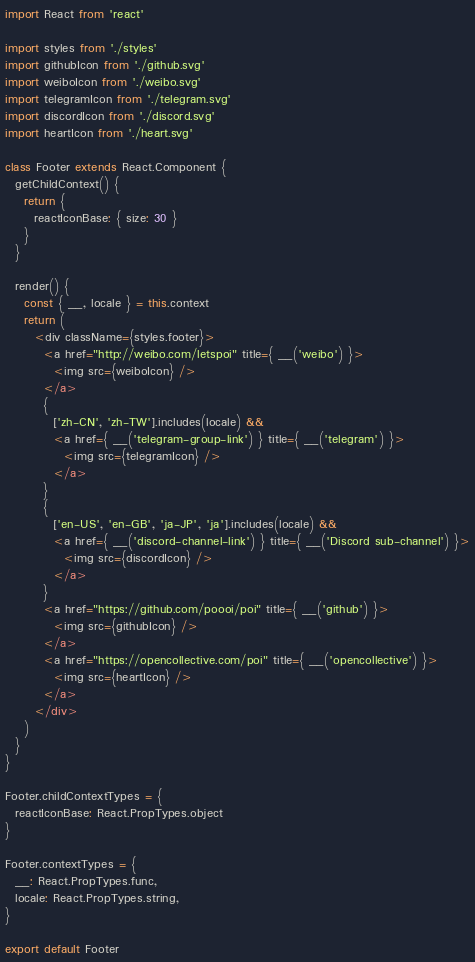<code> <loc_0><loc_0><loc_500><loc_500><_JavaScript_>import React from 'react'

import styles from './styles'
import githubIcon from './github.svg'
import weiboIcon from './weibo.svg'
import telegramIcon from './telegram.svg'
import discordIcon from './discord.svg'
import heartIcon from './heart.svg'

class Footer extends React.Component {
  getChildContext() {
    return {
      reactIconBase: { size: 30 }
    }
  }

  render() {
    const { __, locale } = this.context
    return (
      <div className={styles.footer}>
        <a href="http://weibo.com/letspoi" title={ __('weibo') }>
          <img src={weiboIcon} />
        </a>
        {
          ['zh-CN', 'zh-TW'].includes(locale) &&
          <a href={ __('telegram-group-link') } title={ __('telegram') }>
            <img src={telegramIcon} />
          </a>
        }
        {
          ['en-US', 'en-GB', 'ja-JP', 'ja'].includes(locale) &&
          <a href={ __('discord-channel-link') } title={ __('Discord sub-channel') }>
            <img src={discordIcon} />
          </a>
        }
        <a href="https://github.com/poooi/poi" title={ __('github') }>
          <img src={githubIcon} />
        </a>
        <a href="https://opencollective.com/poi" title={ __('opencollective') }>
          <img src={heartIcon} />
        </a>
      </div>
    )
  }
}

Footer.childContextTypes = {
  reactIconBase: React.PropTypes.object
}

Footer.contextTypes = {
  __: React.PropTypes.func,
  locale: React.PropTypes.string,
}

export default Footer
</code> 